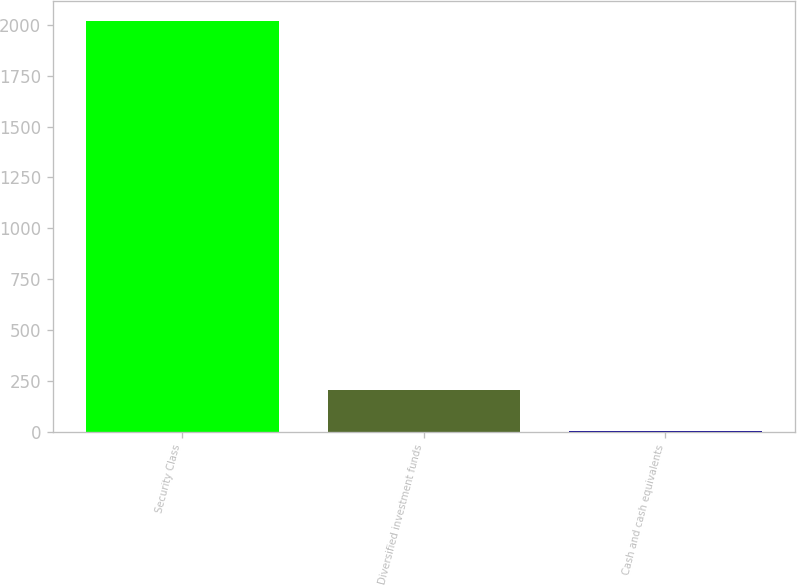Convert chart to OTSL. <chart><loc_0><loc_0><loc_500><loc_500><bar_chart><fcel>Security Class<fcel>Diversified investment funds<fcel>Cash and cash equivalents<nl><fcel>2017<fcel>203.95<fcel>2.5<nl></chart> 